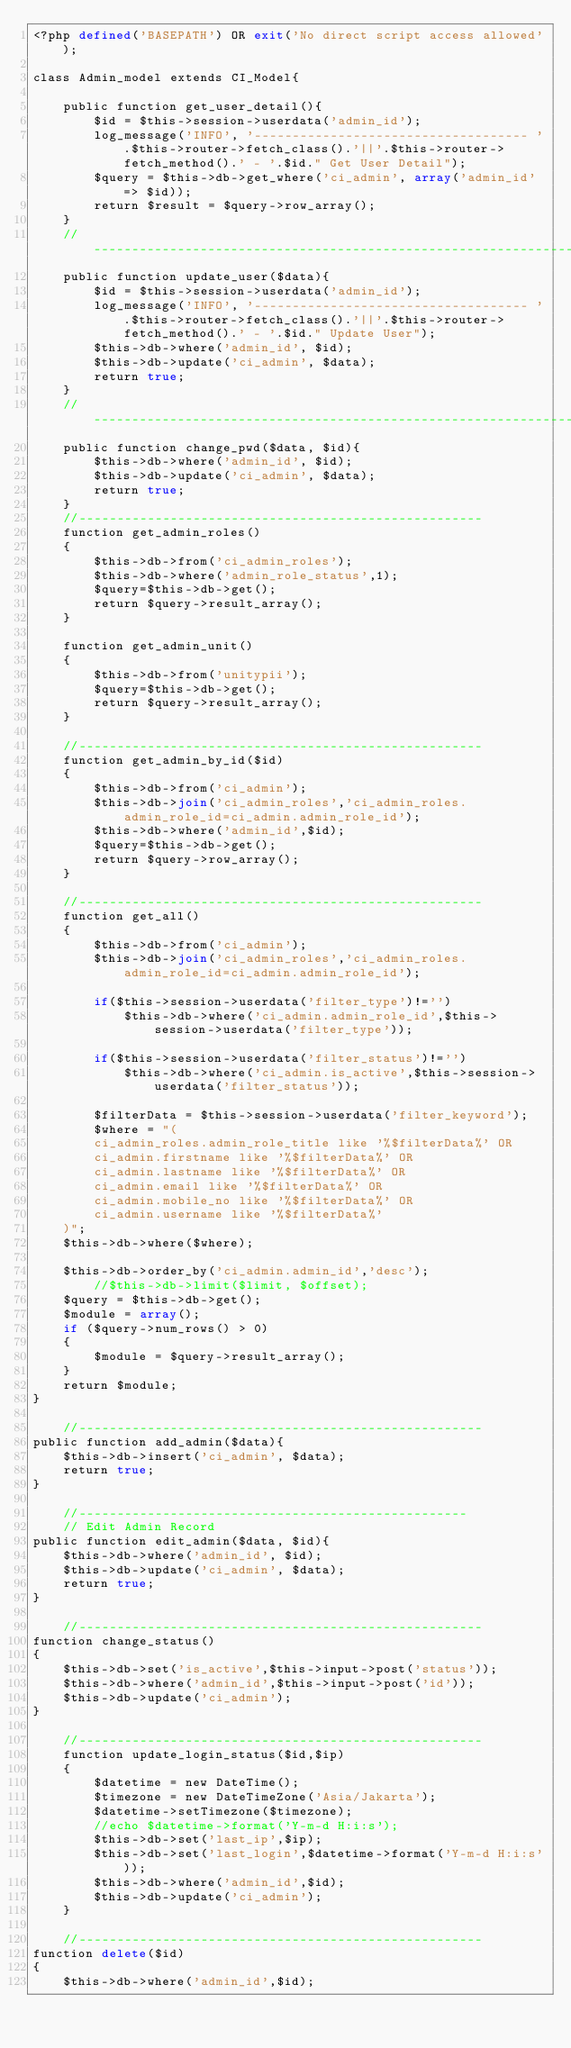<code> <loc_0><loc_0><loc_500><loc_500><_PHP_><?php defined('BASEPATH') OR exit('No direct script access allowed');

class Admin_model extends CI_Model{

	public function get_user_detail(){
		$id = $this->session->userdata('admin_id');
		log_message('INFO', '------------------------------------ '.$this->router->fetch_class().'||'.$this->router->fetch_method().' - '.$id." Get User Detail");
		$query = $this->db->get_where('ci_admin', array('admin_id' => $id));
		return $result = $query->row_array();
	}
	//--------------------------------------------------------------------
	public function update_user($data){
		$id = $this->session->userdata('admin_id');
		log_message('INFO', '------------------------------------ '.$this->router->fetch_class().'||'.$this->router->fetch_method().' - '.$id." Update User");
		$this->db->where('admin_id', $id);
		$this->db->update('ci_admin', $data);
		return true;
	}
	//--------------------------------------------------------------------
	public function change_pwd($data, $id){
		$this->db->where('admin_id', $id);
		$this->db->update('ci_admin', $data);
		return true;
	}
	//-----------------------------------------------------
	function get_admin_roles()
	{
		$this->db->from('ci_admin_roles');
		$this->db->where('admin_role_status',1);
		$query=$this->db->get();
		return $query->result_array();
	}

	function get_admin_unit()
	{
		$this->db->from('unitypii');
		$query=$this->db->get();
		return $query->result_array();
	}

	//-----------------------------------------------------
	function get_admin_by_id($id)
	{
		$this->db->from('ci_admin');
		$this->db->join('ci_admin_roles','ci_admin_roles.admin_role_id=ci_admin.admin_role_id');
		$this->db->where('admin_id',$id);
		$query=$this->db->get();
		return $query->row_array();
	}

	//-----------------------------------------------------
	function get_all()
	{
		$this->db->from('ci_admin');
		$this->db->join('ci_admin_roles','ci_admin_roles.admin_role_id=ci_admin.admin_role_id');
		
		if($this->session->userdata('filter_type')!='')
			$this->db->where('ci_admin.admin_role_id',$this->session->userdata('filter_type'));

		if($this->session->userdata('filter_status')!='')
			$this->db->where('ci_admin.is_active',$this->session->userdata('filter_status'));

		$filterData = $this->session->userdata('filter_keyword');
		$where = "(
		ci_admin_roles.admin_role_title like '%$filterData%' OR
		ci_admin.firstname like '%$filterData%' OR
		ci_admin.lastname like '%$filterData%' OR
		ci_admin.email like '%$filterData%' OR
		ci_admin.mobile_no like '%$filterData%' OR
		ci_admin.username like '%$filterData%'
	)";
	$this->db->where($where);

	$this->db->order_by('ci_admin.admin_id','desc');
		//$this->db->limit($limit, $offset);
	$query = $this->db->get();
	$module = array();
	if ($query->num_rows() > 0) 
	{
		$module = $query->result_array();
	}
	return $module;
}

	//-----------------------------------------------------
public function add_admin($data){
	$this->db->insert('ci_admin', $data);
	return true;
}

	//---------------------------------------------------
	// Edit Admin Record
public function edit_admin($data, $id){
	$this->db->where('admin_id', $id);
	$this->db->update('ci_admin', $data);
	return true;
}

	//-----------------------------------------------------
function change_status()
{		
	$this->db->set('is_active',$this->input->post('status'));
	$this->db->where('admin_id',$this->input->post('id'));
	$this->db->update('ci_admin');
} 

	//-----------------------------------------------------
	function update_login_status($id,$ip)
	{		
		$datetime = new DateTime();
		$timezone = new DateTimeZone('Asia/Jakarta');
		$datetime->setTimezone($timezone);
		//echo $datetime->format('Y-m-d H:i:s');
		$this->db->set('last_ip',$ip);
		$this->db->set('last_login',$datetime->format('Y-m-d H:i:s'));
		$this->db->where('admin_id',$id);
		$this->db->update('ci_admin');
	} 

	//-----------------------------------------------------
function delete($id)
{		
	$this->db->where('admin_id',$id);</code> 